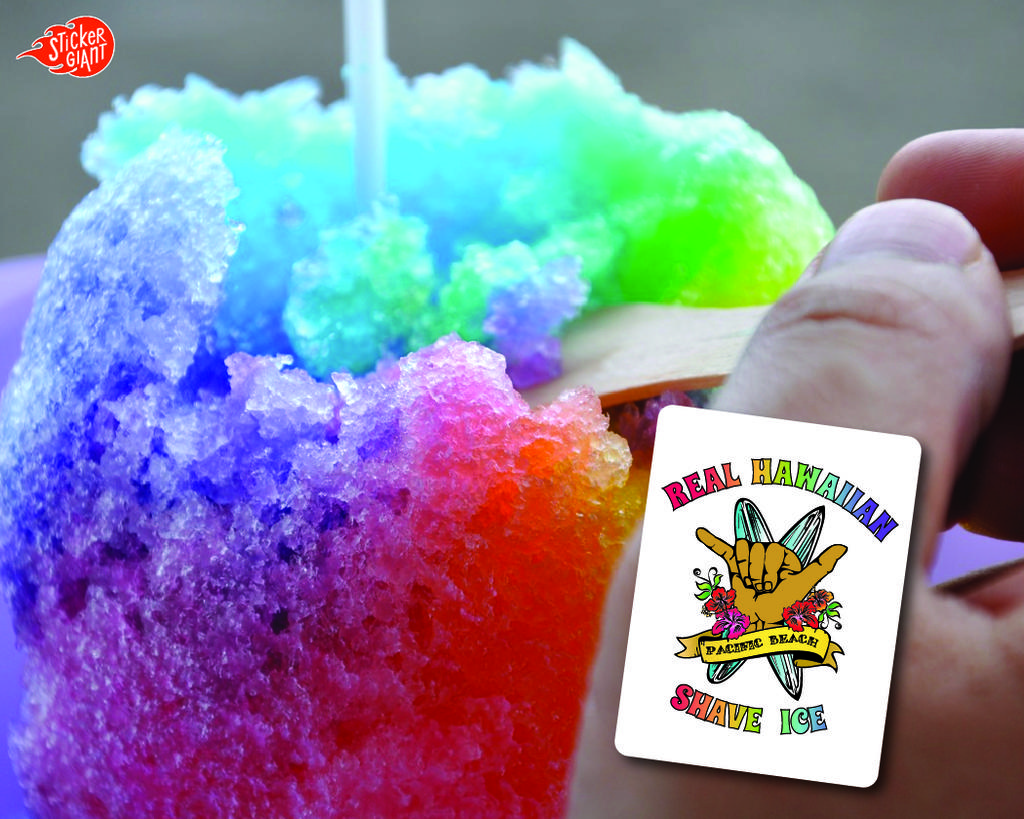What can be seen in the image? There is a person in the image. What is the person holding? The person is holding a wooden item. What else is visible in the image besides the person and the wooden item? There are colorful food items in the image. Can you describe any imperfections or marks on the image? There are watermarks on the image. What vein is visible on the person's hand in the image? There is no visible vein on the person's hand in the image. What is the chance of winning a prize while looking at the image? The image does not depict any game or contest, so there is no chance of winning a prize. 